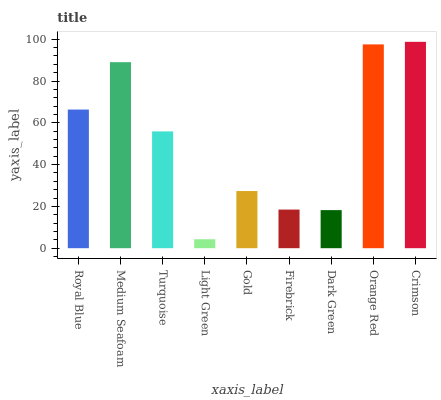Is Light Green the minimum?
Answer yes or no. Yes. Is Crimson the maximum?
Answer yes or no. Yes. Is Medium Seafoam the minimum?
Answer yes or no. No. Is Medium Seafoam the maximum?
Answer yes or no. No. Is Medium Seafoam greater than Royal Blue?
Answer yes or no. Yes. Is Royal Blue less than Medium Seafoam?
Answer yes or no. Yes. Is Royal Blue greater than Medium Seafoam?
Answer yes or no. No. Is Medium Seafoam less than Royal Blue?
Answer yes or no. No. Is Turquoise the high median?
Answer yes or no. Yes. Is Turquoise the low median?
Answer yes or no. Yes. Is Royal Blue the high median?
Answer yes or no. No. Is Light Green the low median?
Answer yes or no. No. 